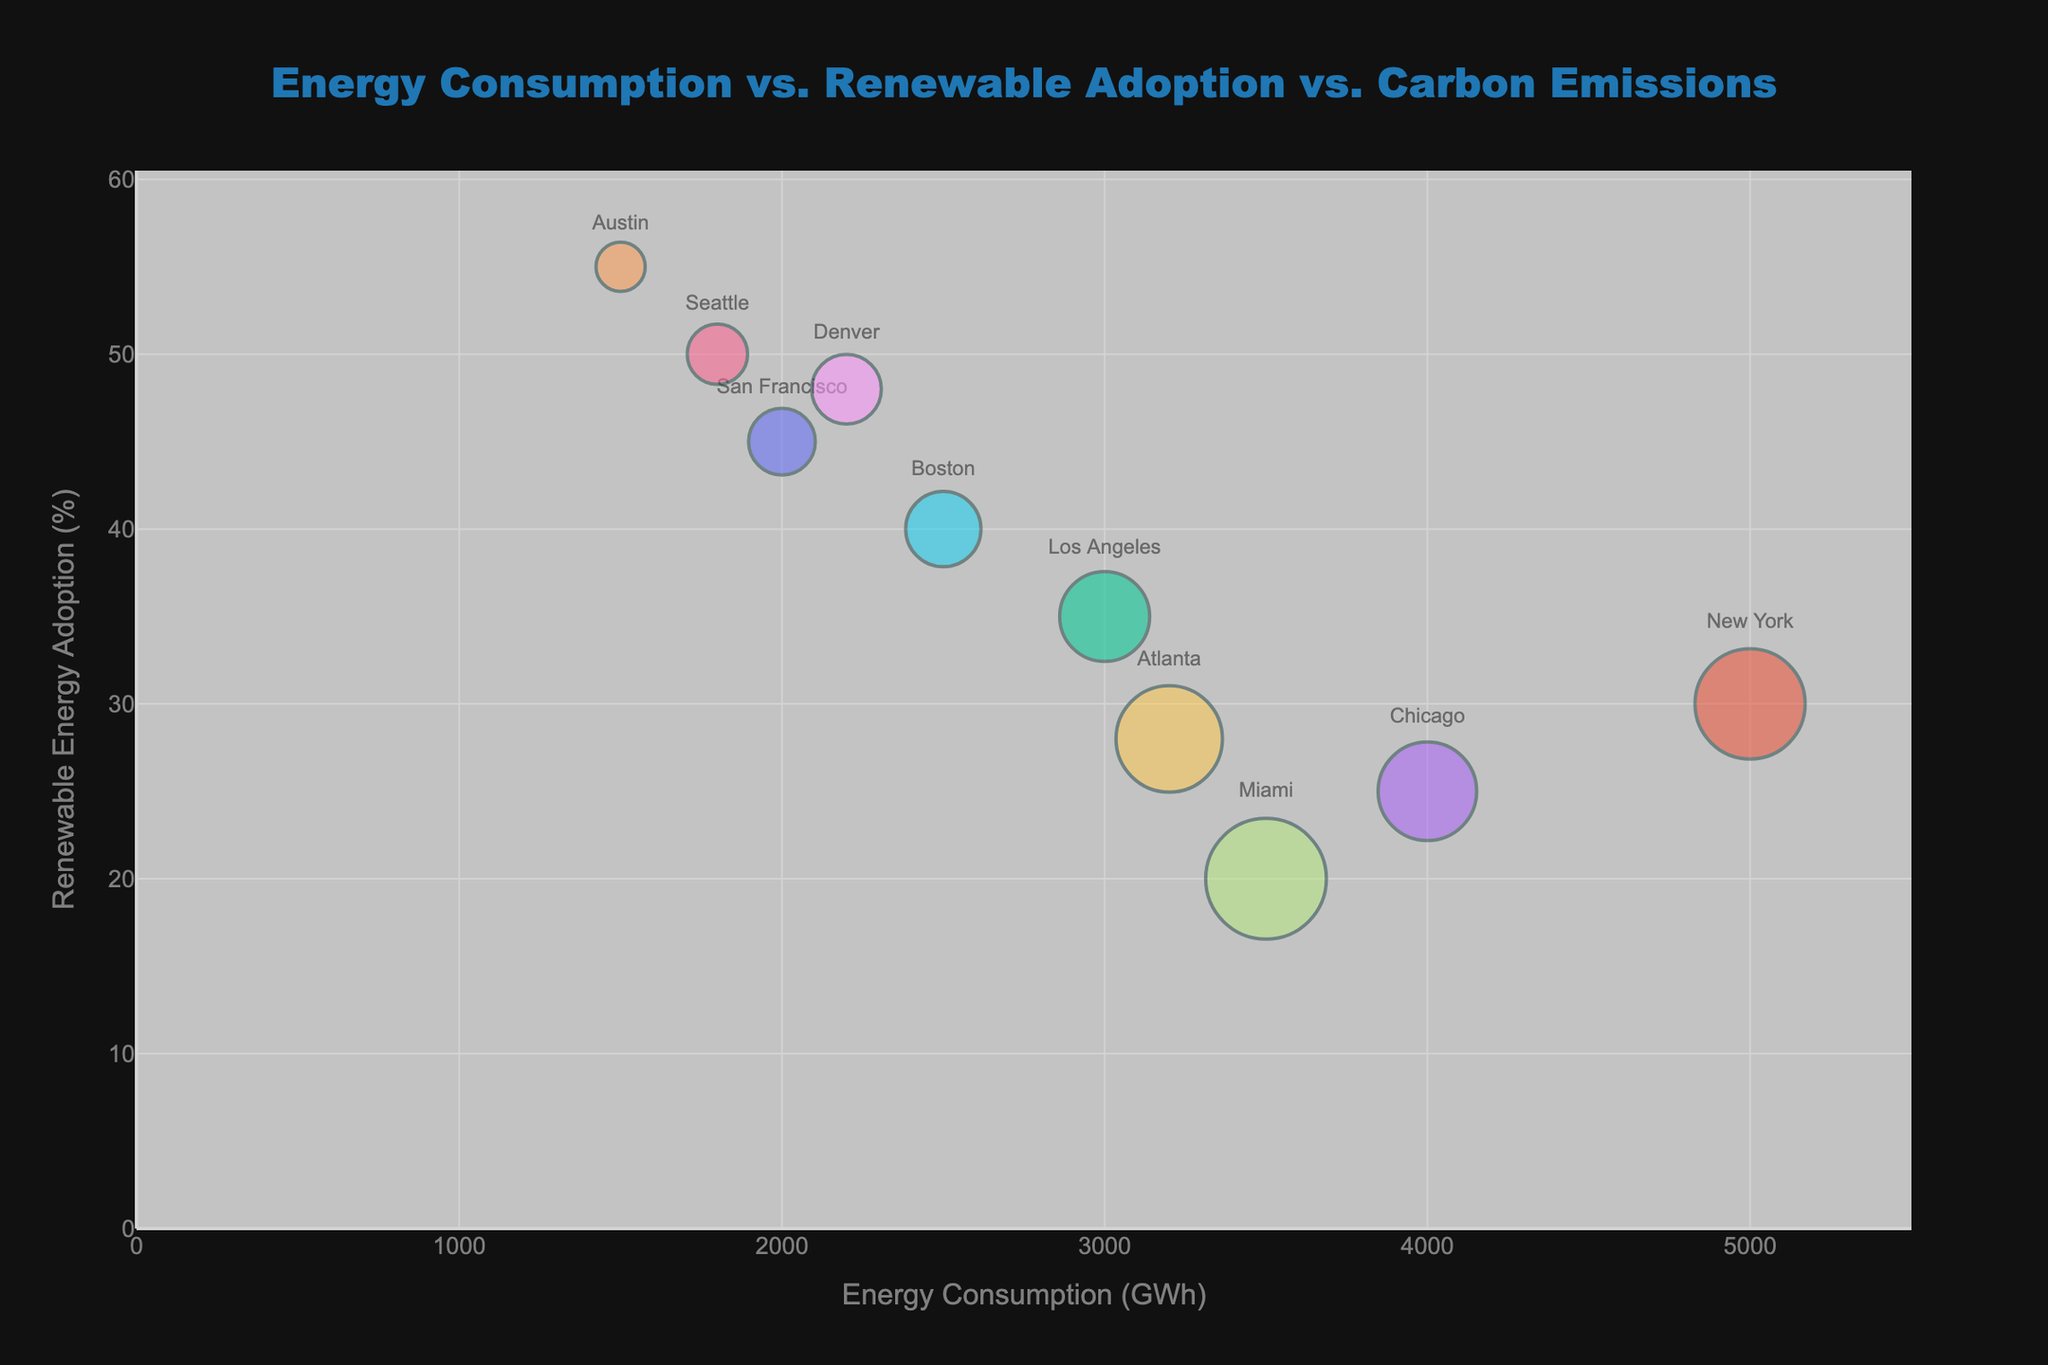What is the city with the highest renewable energy adoption percentage? Observing the y-axis and finding the dot representing the highest point, we see Austin has the highest renewable energy adoption at 55%.
Answer: Austin How many cities have an energy consumption pattern greater than 3000 GWh? Look at the x-axis and find cities with x-coordinates greater than 3000. These are New York, Los Angeles, Chicago, and Atlanta.
Answer: 4 Which city has the lowest carbon emission levels? The size of the bubbles corresponds to carbon emission levels. The smallest bubble represents Austin, with the lowest carbon emission levels of 3 metric tons.
Answer: Austin What is the energy consumption and renewable energy adoption percentage of Boston? Locate the point labeled Boston. The x-coordinate is around 2500 GWh (energy consumption) and the y-coordinate is around 40% (renewable energy adoption).
Answer: 2500 GWh and 40% Between Seattle and Miami, which city has higher carbon emission levels? Compare the size of the bubbles for Seattle and Miami. Miami has a larger bubble, indicating higher carbon emission levels.
Answer: Miami What is the relationship between energy consumption and renewable energy adoption for San Francisco? Find San Francisco on the chart. The x-coordinate is 2000 GWh (energy consumption) and the y-coordinate is 45% (renewable energy adoption). The plot suggests that higher renewable energy adoption does not necessarily correlate with lower energy consumption.
Answer: 2000 GWh and 45% How does Atlanta compare to Denver in terms of energy consumption and renewable energy adoption? Compare the positions of Atlanta and Denver on the chart. Atlanta has higher energy consumption (3200 GWh vs 2200 GWh) but lower renewable energy adoption (28% vs 48%).
Answer: Atlanta has higher energy consumption and lower renewable energy adoption What's the average carbon emission level of the cities that have more than 4000 GWh energy consumption? The cities are New York and Chicago with carbon emissions of 15 and 12 metric tons. The average is (15+12)/2 = 13.5 metric tons.
Answer: 13.5 metric tons Which city has the highest energy consumption combined with significant renewable energy adoption (above 35%)? Check the cities where renewable energy adoption is above 35%. Los Angeles (3000 GWh) has the highest energy consumption among them.
Answer: Los Angeles 